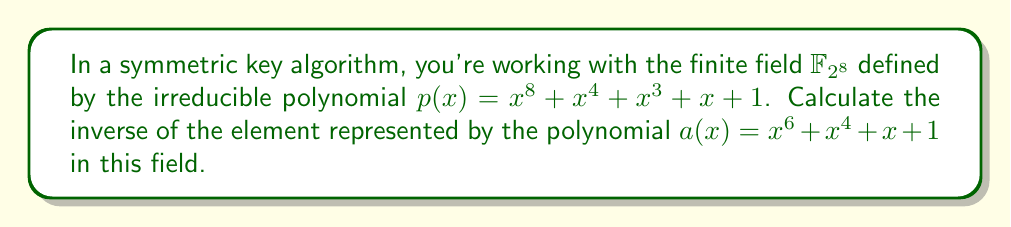What is the answer to this math problem? To find the inverse of an element in a finite field, we can use the extended Euclidean algorithm. We need to find polynomials $s(x)$ and $t(x)$ such that:

$$s(x)a(x) + t(x)p(x) = 1$$

Let's apply the extended Euclidean algorithm:

1) $p(x) = (x^2 + x)a(x) + (x^3 + x^2 + 1)$
2) $a(x) = (x^3 + x^2 + x + 1)(x^3 + x^2 + 1) + (x^2 + 1)$
3) $(x^3 + x^2 + 1) = (x)(x^2 + 1) + (x^2 + x + 1)$
4) $(x^2 + 1) = (x + 1)(x^2 + x + 1) + 1$

Working backwards:

$$1 = (x^2 + 1) + (x + 1)(x^2 + x + 1)$$
$$1 = (x^2 + 1) + (x + 1)((x^3 + x^2 + 1) + x(x^2 + 1))$$
$$1 = (x^3 + x^2 + x + 1)(x^2 + 1) + (x + 1)(x^3 + x^2 + 1)$$
$$1 = (x^3 + x^2 + x + 1)(x^2 + 1) + (x + 1)(p(x) + (x^2 + x)a(x))$$
$$1 = ((x^5 + x^4 + x^3 + x^2) + (x^3 + x^2 + x + 1))a(x) + (x + 1)p(x)$$

Therefore, the inverse of $a(x)$ is:

$$a^{-1}(x) = x^5 + x^4 + x^3 + x^2 + x^3 + x^2 + x + 1 = x^5 + x^4 + x + 1$$

This can be verified by multiplying $a(x)$ and $a^{-1}(x)$ modulo $p(x)$:

$$(x^6 + x^4 + x + 1)(x^5 + x^4 + x + 1) \equiv 1 \pmod{p(x)}$$
Answer: $a^{-1}(x) = x^5 + x^4 + x + 1$ 